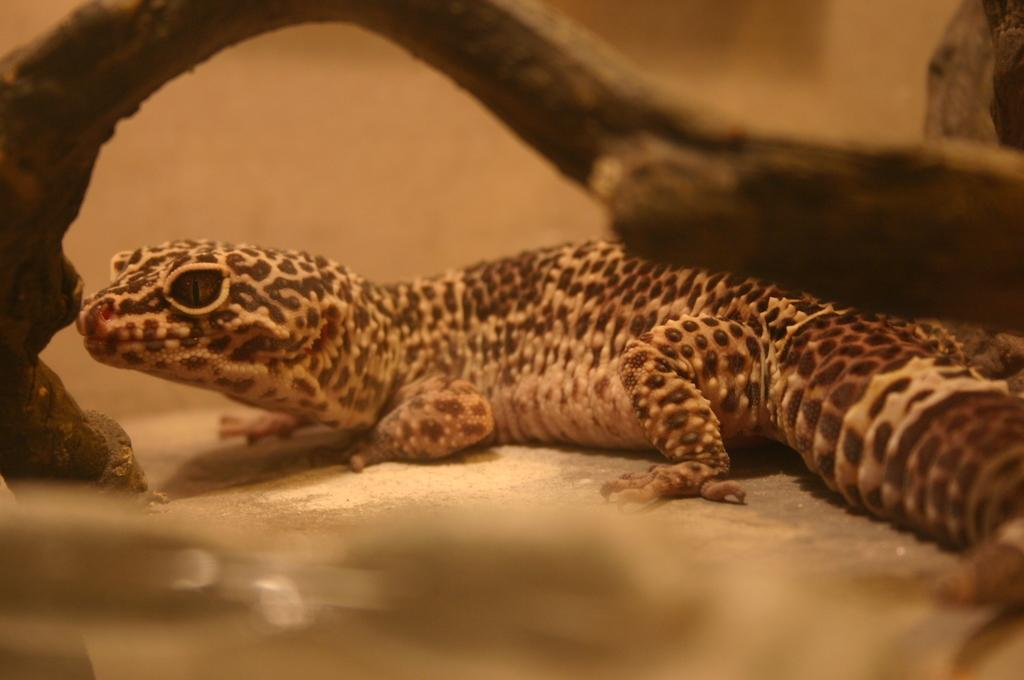What type of animal is in the image? There is a reptile in the image. What family does the reptile belong to? The reptile belongs to the lizard family. What is the specific name of the reptile? The reptile is named western whiptail. What object can be seen in the image besides the reptile? There is a wooden branch in the image. What page of the book does the reptile appear on in the image? There is no book present in the image, so it is not possible to determine which page the reptile appears on. 